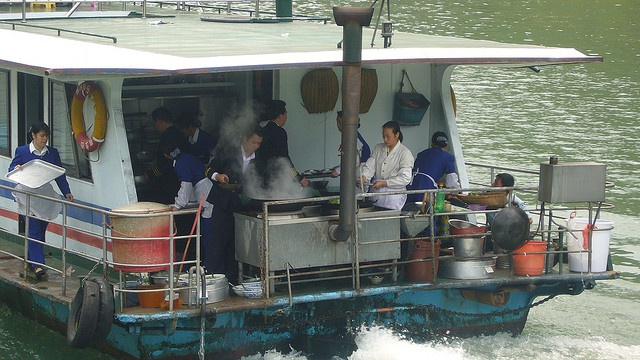Describe the objects in this image and their specific colors. I can see boat in lavender, gray, black, ivory, and darkgray tones, oven in lavender, gray, black, and darkgray tones, people in lavender, black, gray, and darkgray tones, people in lavender, navy, gray, black, and darkgray tones, and people in lavender, darkgray, gray, black, and lightgray tones in this image. 